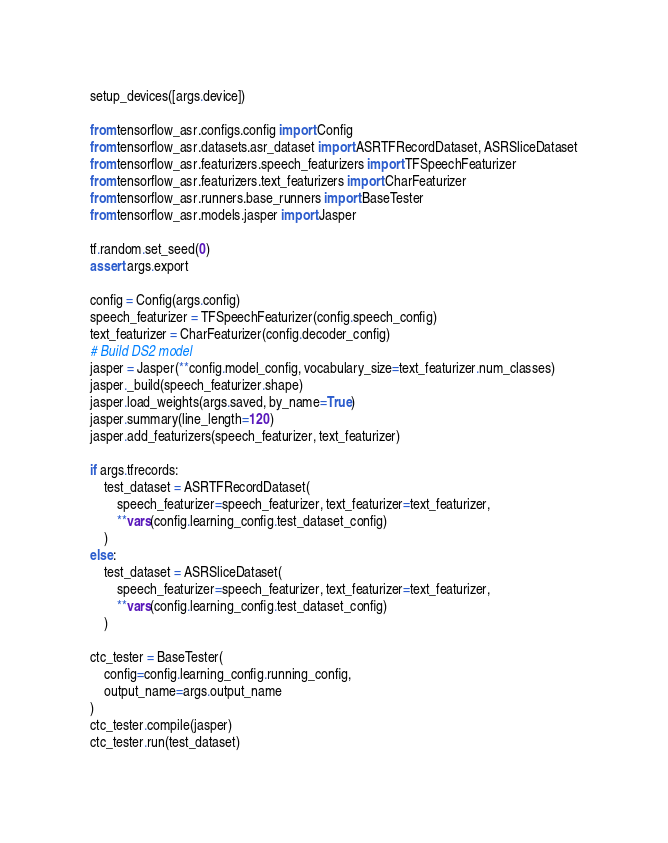<code> <loc_0><loc_0><loc_500><loc_500><_Python_>setup_devices([args.device])

from tensorflow_asr.configs.config import Config
from tensorflow_asr.datasets.asr_dataset import ASRTFRecordDataset, ASRSliceDataset
from tensorflow_asr.featurizers.speech_featurizers import TFSpeechFeaturizer
from tensorflow_asr.featurizers.text_featurizers import CharFeaturizer
from tensorflow_asr.runners.base_runners import BaseTester
from tensorflow_asr.models.jasper import Jasper

tf.random.set_seed(0)
assert args.export

config = Config(args.config)
speech_featurizer = TFSpeechFeaturizer(config.speech_config)
text_featurizer = CharFeaturizer(config.decoder_config)
# Build DS2 model
jasper = Jasper(**config.model_config, vocabulary_size=text_featurizer.num_classes)
jasper._build(speech_featurizer.shape)
jasper.load_weights(args.saved, by_name=True)
jasper.summary(line_length=120)
jasper.add_featurizers(speech_featurizer, text_featurizer)

if args.tfrecords:
    test_dataset = ASRTFRecordDataset(
        speech_featurizer=speech_featurizer, text_featurizer=text_featurizer,
        **vars(config.learning_config.test_dataset_config)
    )
else:
    test_dataset = ASRSliceDataset(
        speech_featurizer=speech_featurizer, text_featurizer=text_featurizer,
        **vars(config.learning_config.test_dataset_config)
    )

ctc_tester = BaseTester(
    config=config.learning_config.running_config,
    output_name=args.output_name
)
ctc_tester.compile(jasper)
ctc_tester.run(test_dataset)
</code> 